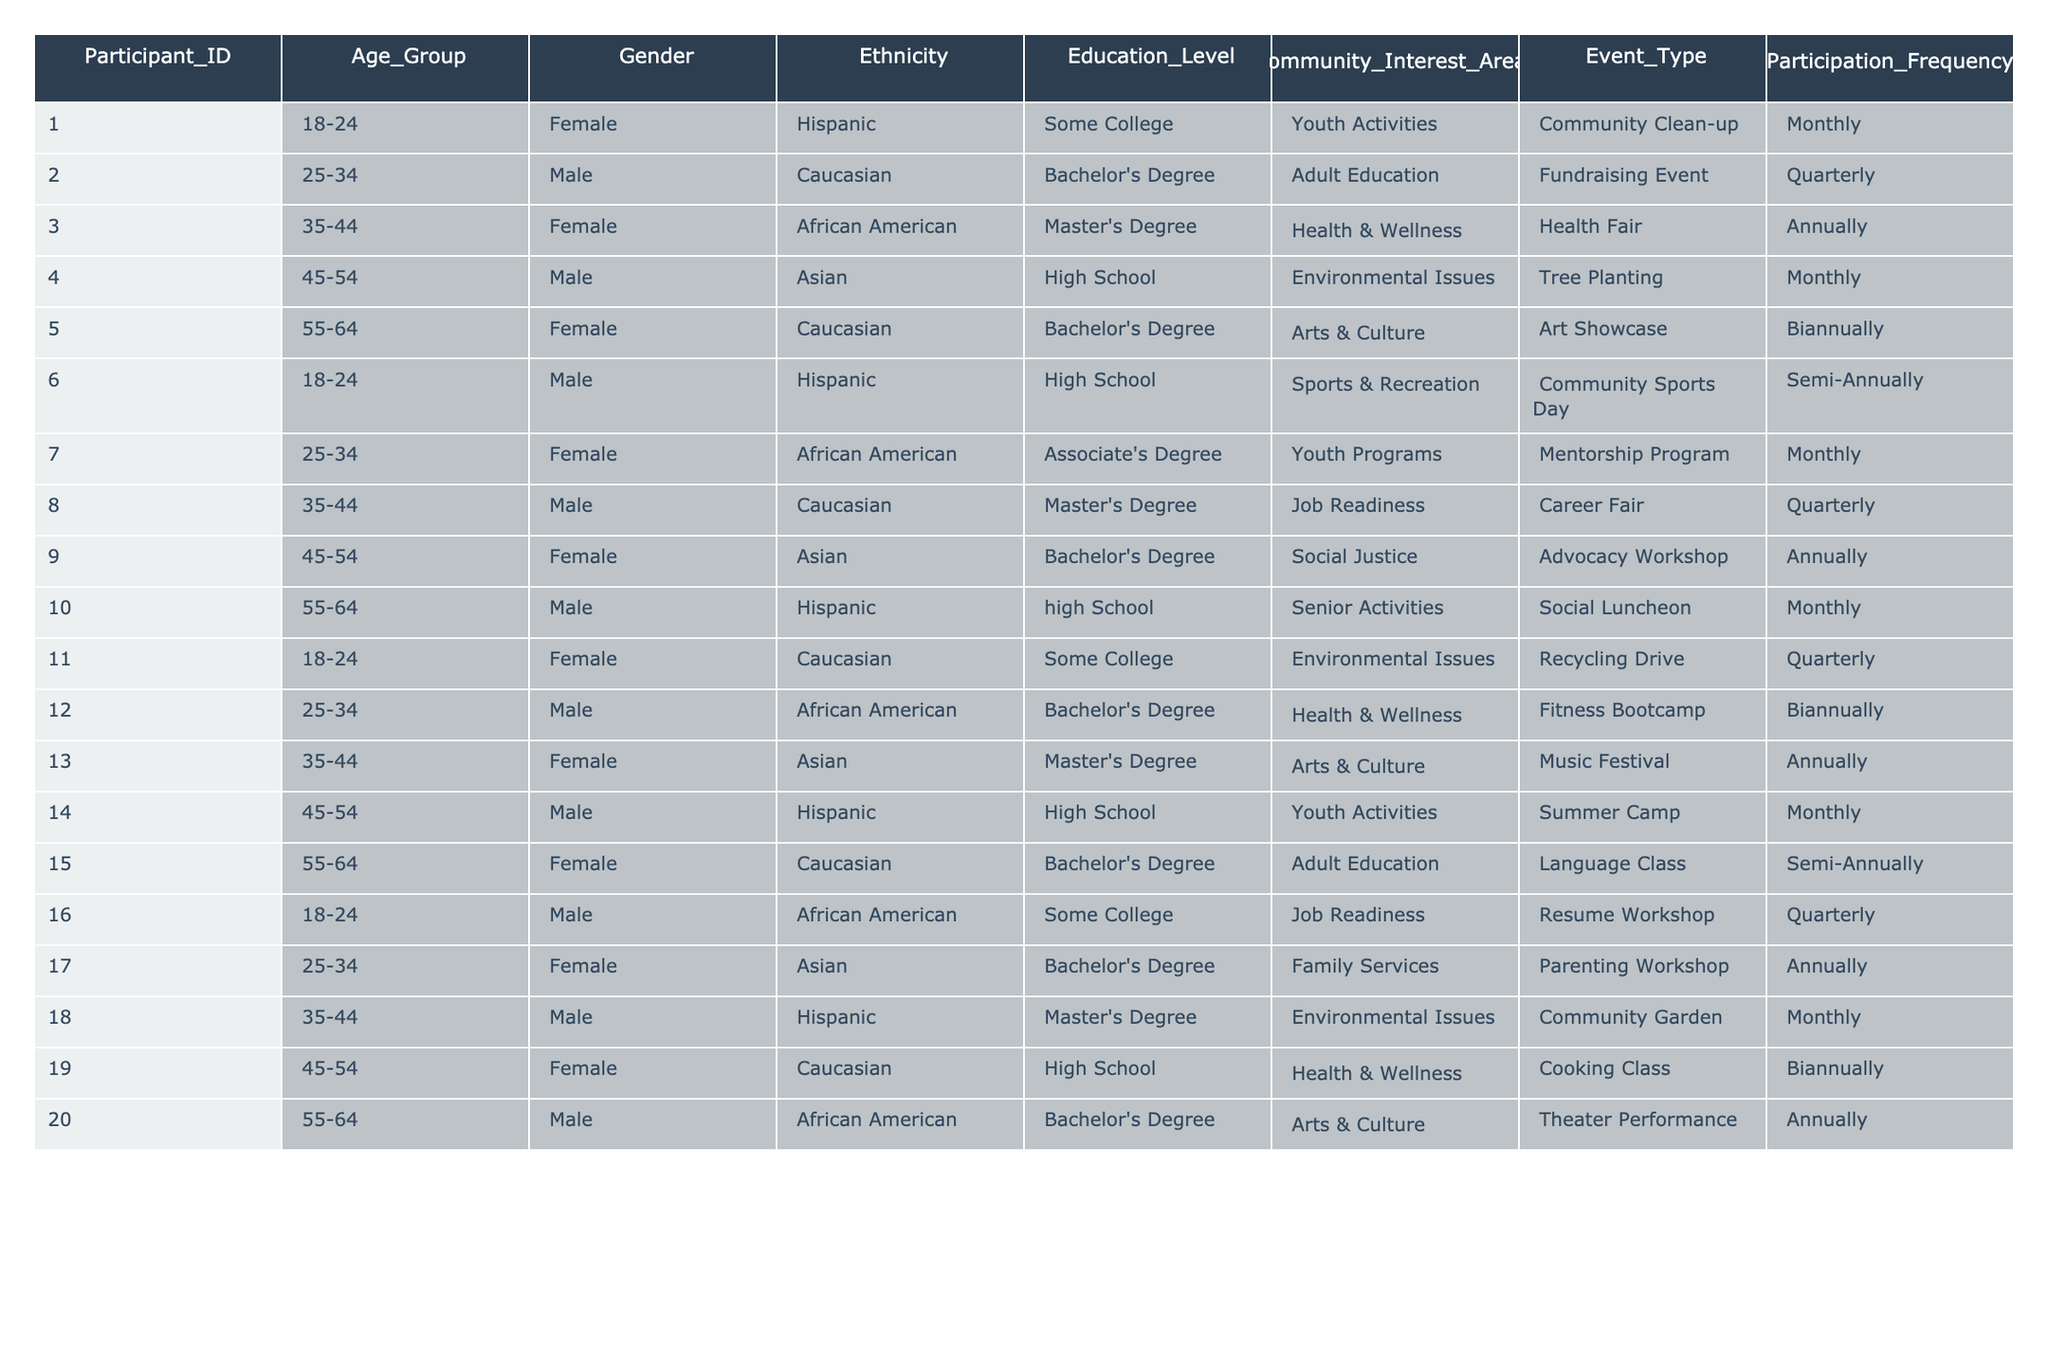What is the most common event type participants attended? By examining the "Event_Type" column, I can count the occurrences of each event type. Looking at the table, "Community Clean-up," "Fundraising Event," and "Social Luncheon" seem to have multiple participants attending, but "Community Clean-up" appears the most frequently by 4 instances.
Answer: Community Clean-up How many male participants are there aged 45-54? I look for participants in the "Age_Group" column indicating 45-54 and check the "Gender" column for male. In the table, there are two records fitting this criteria (Participant_IDs 4 and 14).
Answer: 2 What percentage of participants are from the Hispanic ethnicity? To find the percentage, I count the total number of participants and the number of Hispanic participants. There are 5 Hispanic participants out of 20 total participants. The percentage is (5/20) * 100 = 25%.
Answer: 25% Which age group has the highest participation frequency in the "Monthly" category? I examine the "Age_Group" and "Participation_Frequency" columns together to identify which age group has the most entries under "Monthly." The "18-24" and "45-54" age groups both have 4 entries each, which is the highest among all age groups.
Answer: 18-24 and 45-54 What is the average education level of participants aged 25-34? First, I find the participants in the 25-34 age group, which includes 5 participants. Their education levels are "Bachelor's Degree," "Bachelor's Degree," "Bachelor's Degree," "Associate's Degree," and "Bachelor's Degree." Assuming 2.5 for Associate's, the average level is (4*3 + 2) / 5 = 3.4, which rounds to approximately "Bachelor's Degree."
Answer: Bachelor's Degree Is there a participant with a Master's Degree who attended an event more frequently than twice a year? I review the "Education_Level" and "Participation_Frequency" columns for participants with a Master's Degree. The table shows participants with a Master's Degree who participate "Monthly" or "Quarterly." Therefore, there are two participants meeting this criteria.
Answer: Yes How many participants identified as Female are involved in Arts & Culture? I filter through the "Gender" for Female and check the "Community_Interest_Areas" for Arts & Culture. There are two Female participants (Participant_IDs 5 and 13) engaged in Arts & Culture activities.
Answer: 2 What is the ratio of Male to Female participants who attend events annually? I count the Male and Female participants attending annually. There are 4 Females (Participant_IDs 3, 9, 13, and 20) and 2 Males (Participant_IDs 3, 18) attending annually. Therefore, the ratio of Male to Female is 2:4, simplified to 1:2.
Answer: 1:2 How many total events are categorized as "Biannually"? I go through the "Event_Type" column and count instances labeled as Biannually. There are 4 events listed in the "Participation_Frequency" column tagged as Biannually.
Answer: 4 Which ethnic group has the highest representation among participants? I assess the "Ethnicity" entries, counting instances of each group. Based on these counts, "Caucasian" emerges as the most represented ethnicity with a total of 6 participants.
Answer: Caucasian 